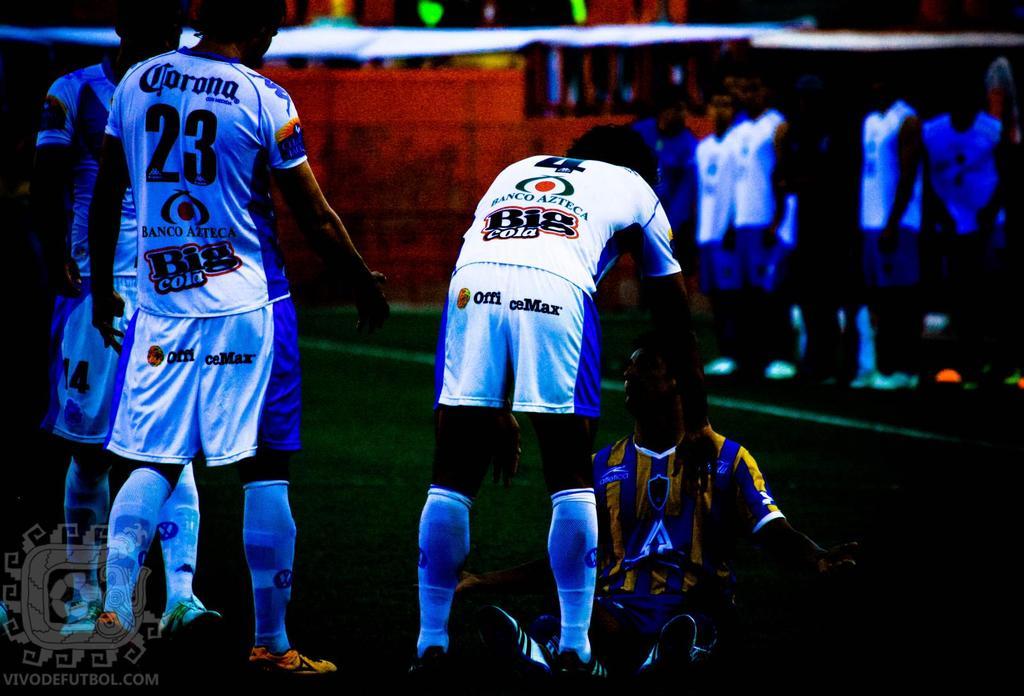Which player on the white team is holding out one of his hands toward his opponent?
Give a very brief answer. 23. What is the number of the player on the very left?
Keep it short and to the point. 23. 